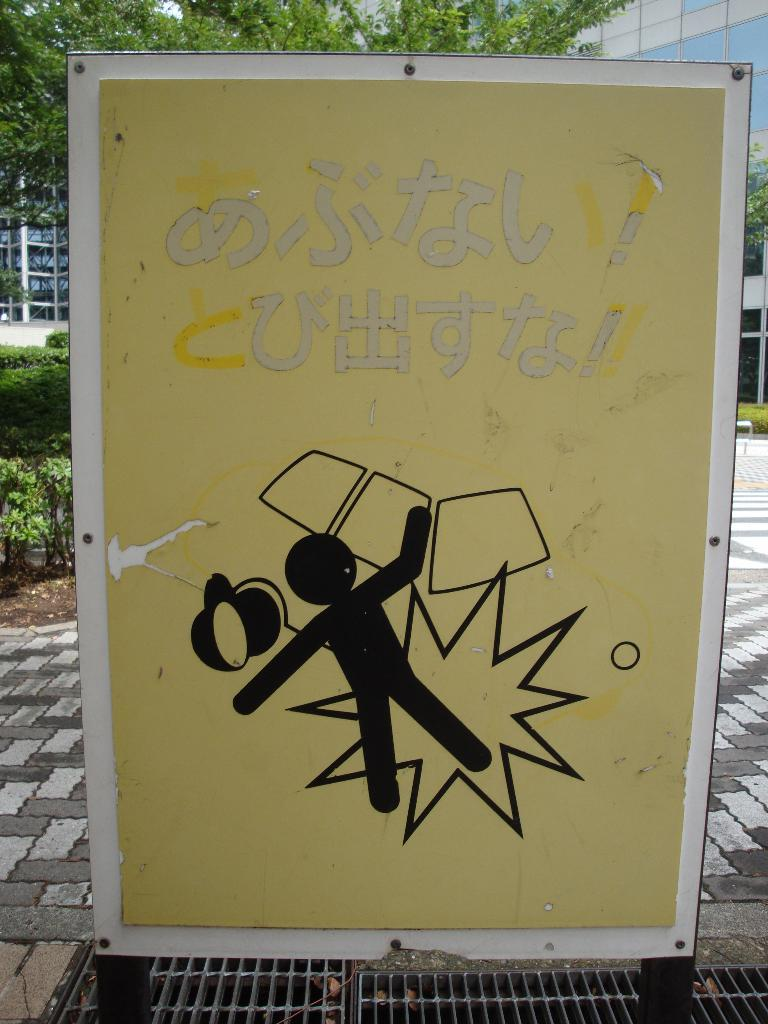What is depicted on the board in the image? There is a painting on the board in the image. What can be seen above the painting on the board? There is something written above the painting on the board. What is visible in the background of the image? There is a building, trees, and plants in the background of the image. What color is the vein visible in the painting? There is no vein visible in the painting, as it is a painting on a board and not a biological representation. 